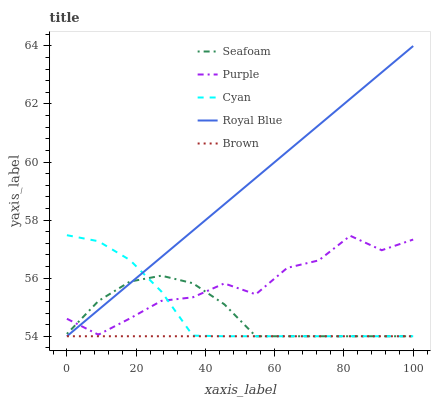Does Brown have the minimum area under the curve?
Answer yes or no. Yes. Does Royal Blue have the maximum area under the curve?
Answer yes or no. Yes. Does Cyan have the minimum area under the curve?
Answer yes or no. No. Does Cyan have the maximum area under the curve?
Answer yes or no. No. Is Brown the smoothest?
Answer yes or no. Yes. Is Purple the roughest?
Answer yes or no. Yes. Is Cyan the smoothest?
Answer yes or no. No. Is Cyan the roughest?
Answer yes or no. No. Does Cyan have the lowest value?
Answer yes or no. Yes. Does Royal Blue have the highest value?
Answer yes or no. Yes. Does Cyan have the highest value?
Answer yes or no. No. Is Brown less than Purple?
Answer yes or no. Yes. Is Purple greater than Brown?
Answer yes or no. Yes. Does Royal Blue intersect Seafoam?
Answer yes or no. Yes. Is Royal Blue less than Seafoam?
Answer yes or no. No. Is Royal Blue greater than Seafoam?
Answer yes or no. No. Does Brown intersect Purple?
Answer yes or no. No. 